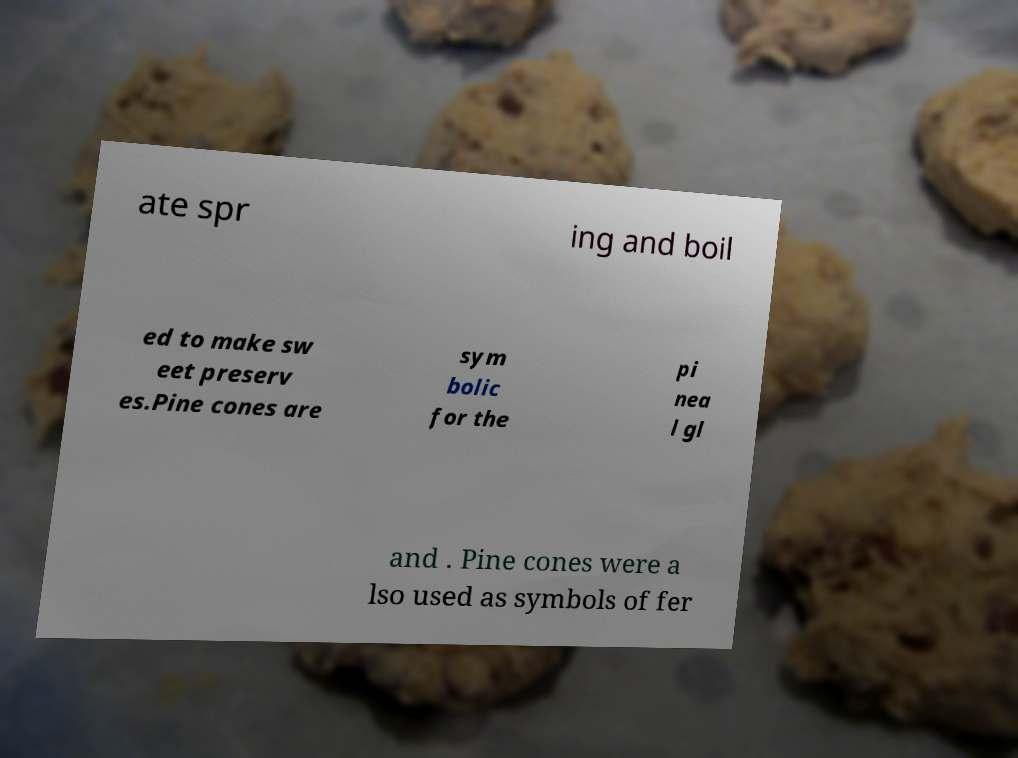I need the written content from this picture converted into text. Can you do that? ate spr ing and boil ed to make sw eet preserv es.Pine cones are sym bolic for the pi nea l gl and . Pine cones were a lso used as symbols of fer 